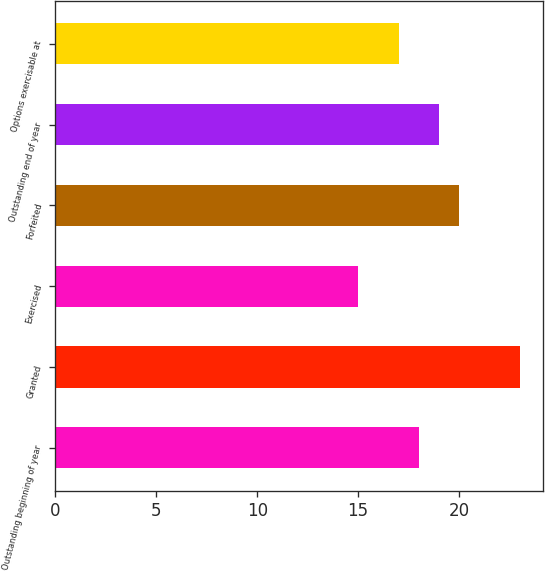Convert chart. <chart><loc_0><loc_0><loc_500><loc_500><bar_chart><fcel>Outstanding beginning of year<fcel>Granted<fcel>Exercised<fcel>Forfeited<fcel>Outstanding end of year<fcel>Options exercisable at<nl><fcel>18<fcel>23<fcel>15<fcel>20<fcel>19<fcel>17<nl></chart> 